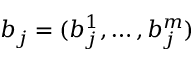Convert formula to latex. <formula><loc_0><loc_0><loc_500><loc_500>b _ { j } = ( b _ { j } ^ { 1 } , \dots , b _ { j } ^ { m } )</formula> 